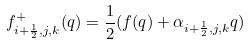<formula> <loc_0><loc_0><loc_500><loc_500>f ^ { + } _ { i + \frac { 1 } { 2 } , j , k } ( q ) = \frac { 1 } { 2 } ( f ( q ) + \alpha _ { i + \frac { 1 } { 2 } , j , k } q )</formula> 